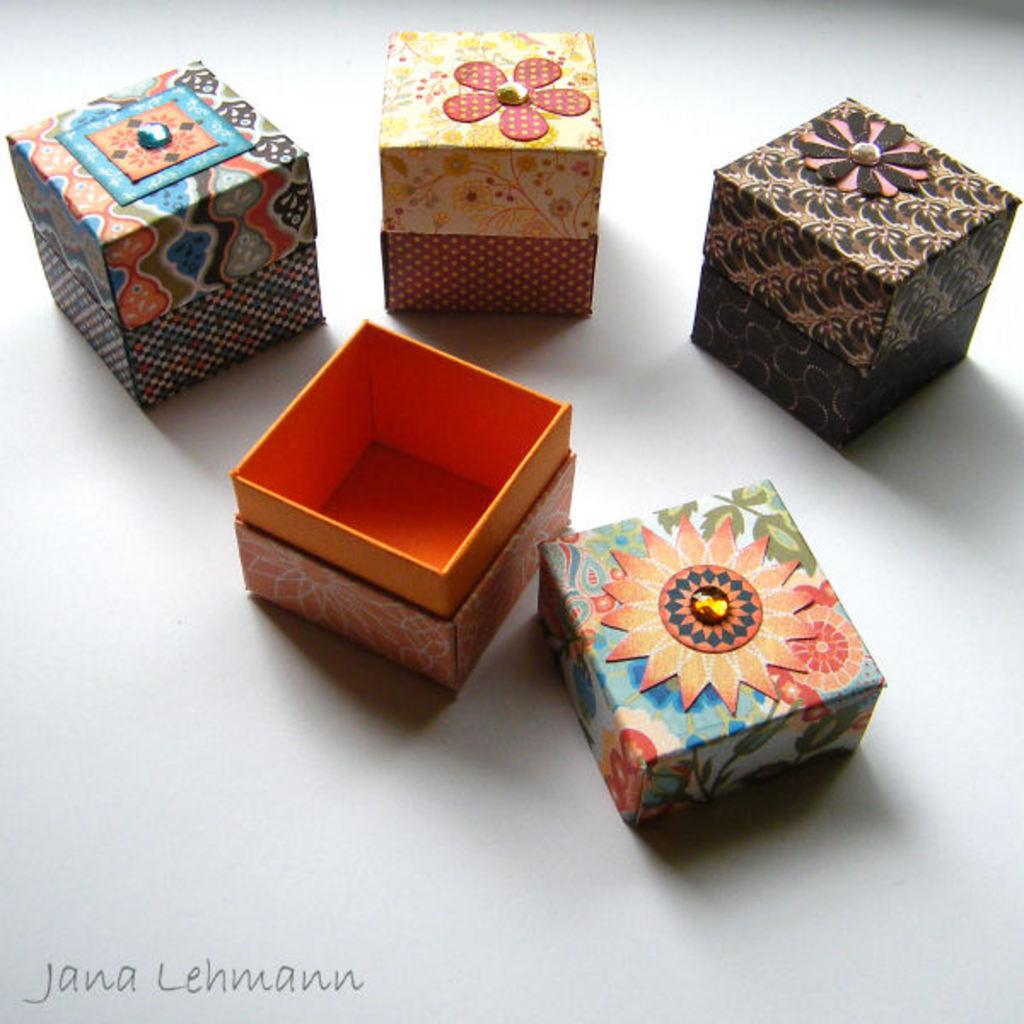Who took this photo?
Provide a succinct answer. Jana lehmann. 